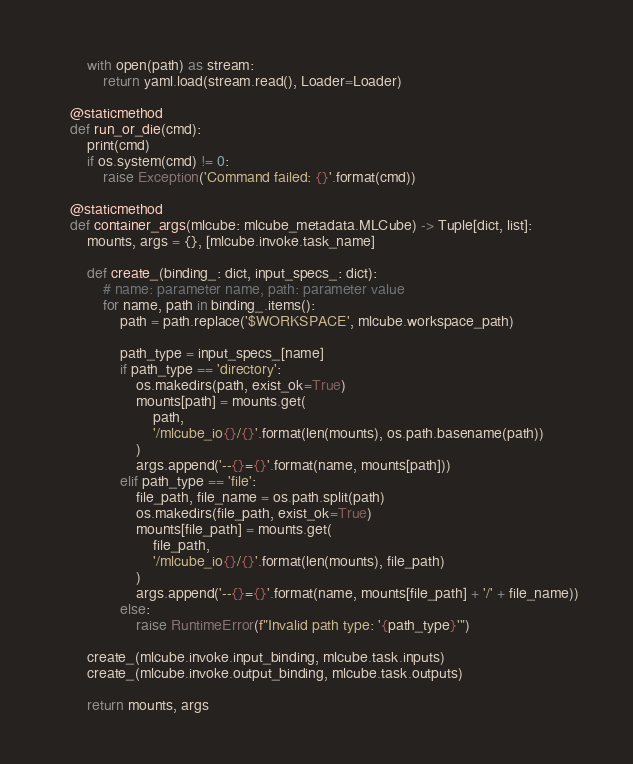<code> <loc_0><loc_0><loc_500><loc_500><_Python_>        with open(path) as stream:
            return yaml.load(stream.read(), Loader=Loader)

    @staticmethod
    def run_or_die(cmd):
        print(cmd)
        if os.system(cmd) != 0:
            raise Exception('Command failed: {}'.format(cmd))

    @staticmethod
    def container_args(mlcube: mlcube_metadata.MLCube) -> Tuple[dict, list]:
        mounts, args = {}, [mlcube.invoke.task_name]

        def create_(binding_: dict, input_specs_: dict):
            # name: parameter name, path: parameter value
            for name, path in binding_.items():
                path = path.replace('$WORKSPACE', mlcube.workspace_path)

                path_type = input_specs_[name]
                if path_type == 'directory':
                    os.makedirs(path, exist_ok=True)
                    mounts[path] = mounts.get(
                        path,
                        '/mlcube_io{}/{}'.format(len(mounts), os.path.basename(path))
                    )
                    args.append('--{}={}'.format(name, mounts[path]))
                elif path_type == 'file':
                    file_path, file_name = os.path.split(path)
                    os.makedirs(file_path, exist_ok=True)
                    mounts[file_path] = mounts.get(
                        file_path,
                        '/mlcube_io{}/{}'.format(len(mounts), file_path)
                    )
                    args.append('--{}={}'.format(name, mounts[file_path] + '/' + file_name))
                else:
                    raise RuntimeError(f"Invalid path type: '{path_type}'")

        create_(mlcube.invoke.input_binding, mlcube.task.inputs)
        create_(mlcube.invoke.output_binding, mlcube.task.outputs)

        return mounts, args
</code> 